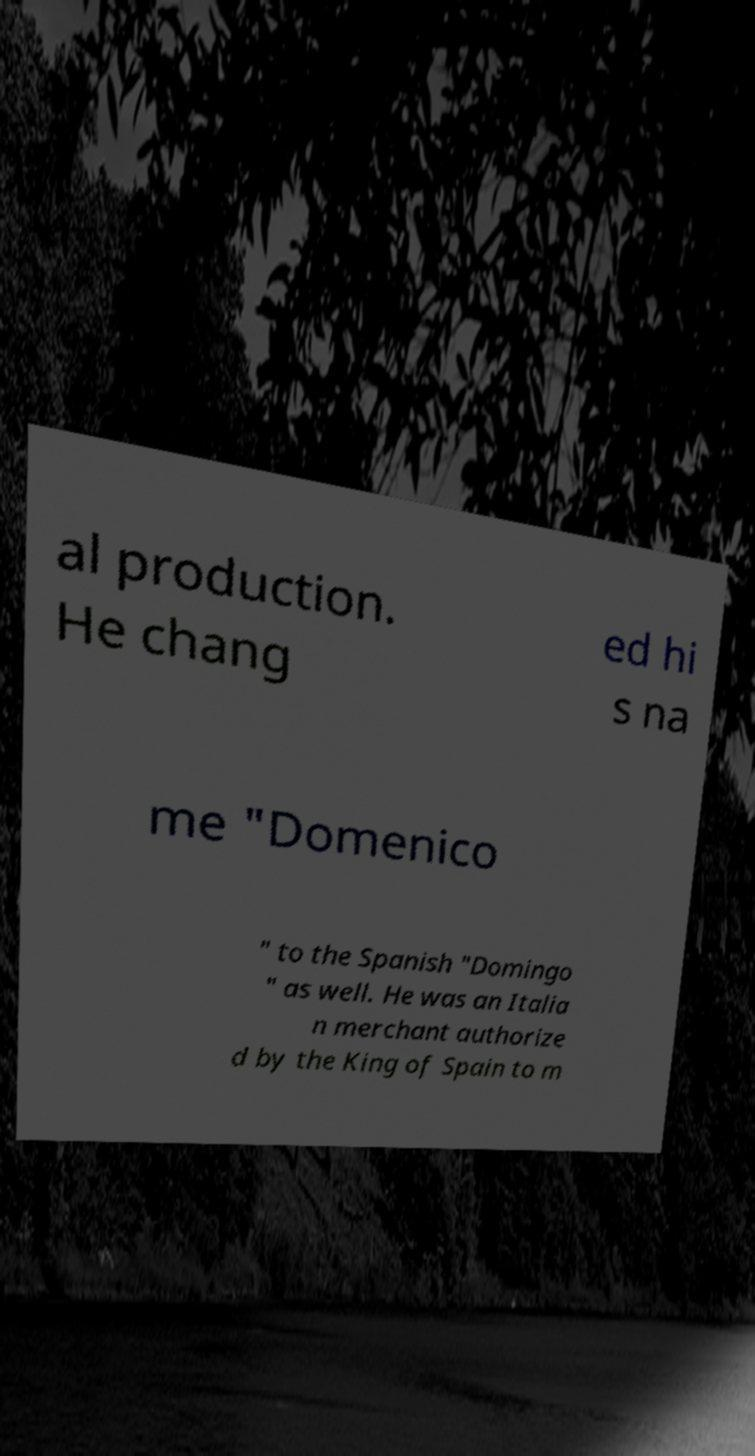Can you read and provide the text displayed in the image?This photo seems to have some interesting text. Can you extract and type it out for me? al production. He chang ed hi s na me "Domenico " to the Spanish "Domingo " as well. He was an Italia n merchant authorize d by the King of Spain to m 